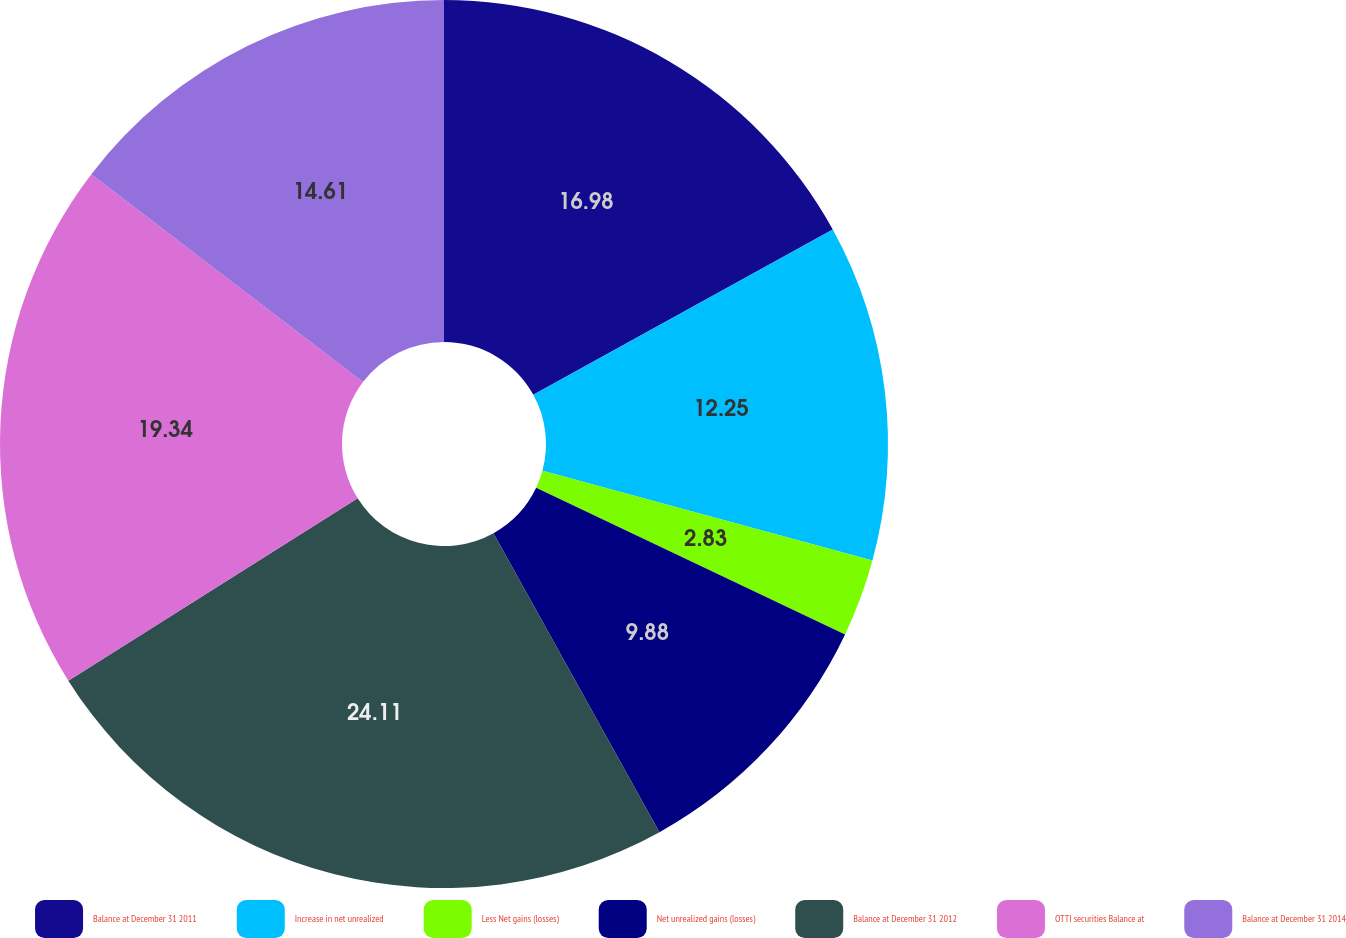<chart> <loc_0><loc_0><loc_500><loc_500><pie_chart><fcel>Balance at December 31 2011<fcel>Increase in net unrealized<fcel>Less Net gains (losses)<fcel>Net unrealized gains (losses)<fcel>Balance at December 31 2012<fcel>OTTI securities Balance at<fcel>Balance at December 31 2014<nl><fcel>16.98%<fcel>12.25%<fcel>2.83%<fcel>9.88%<fcel>24.12%<fcel>19.34%<fcel>14.61%<nl></chart> 